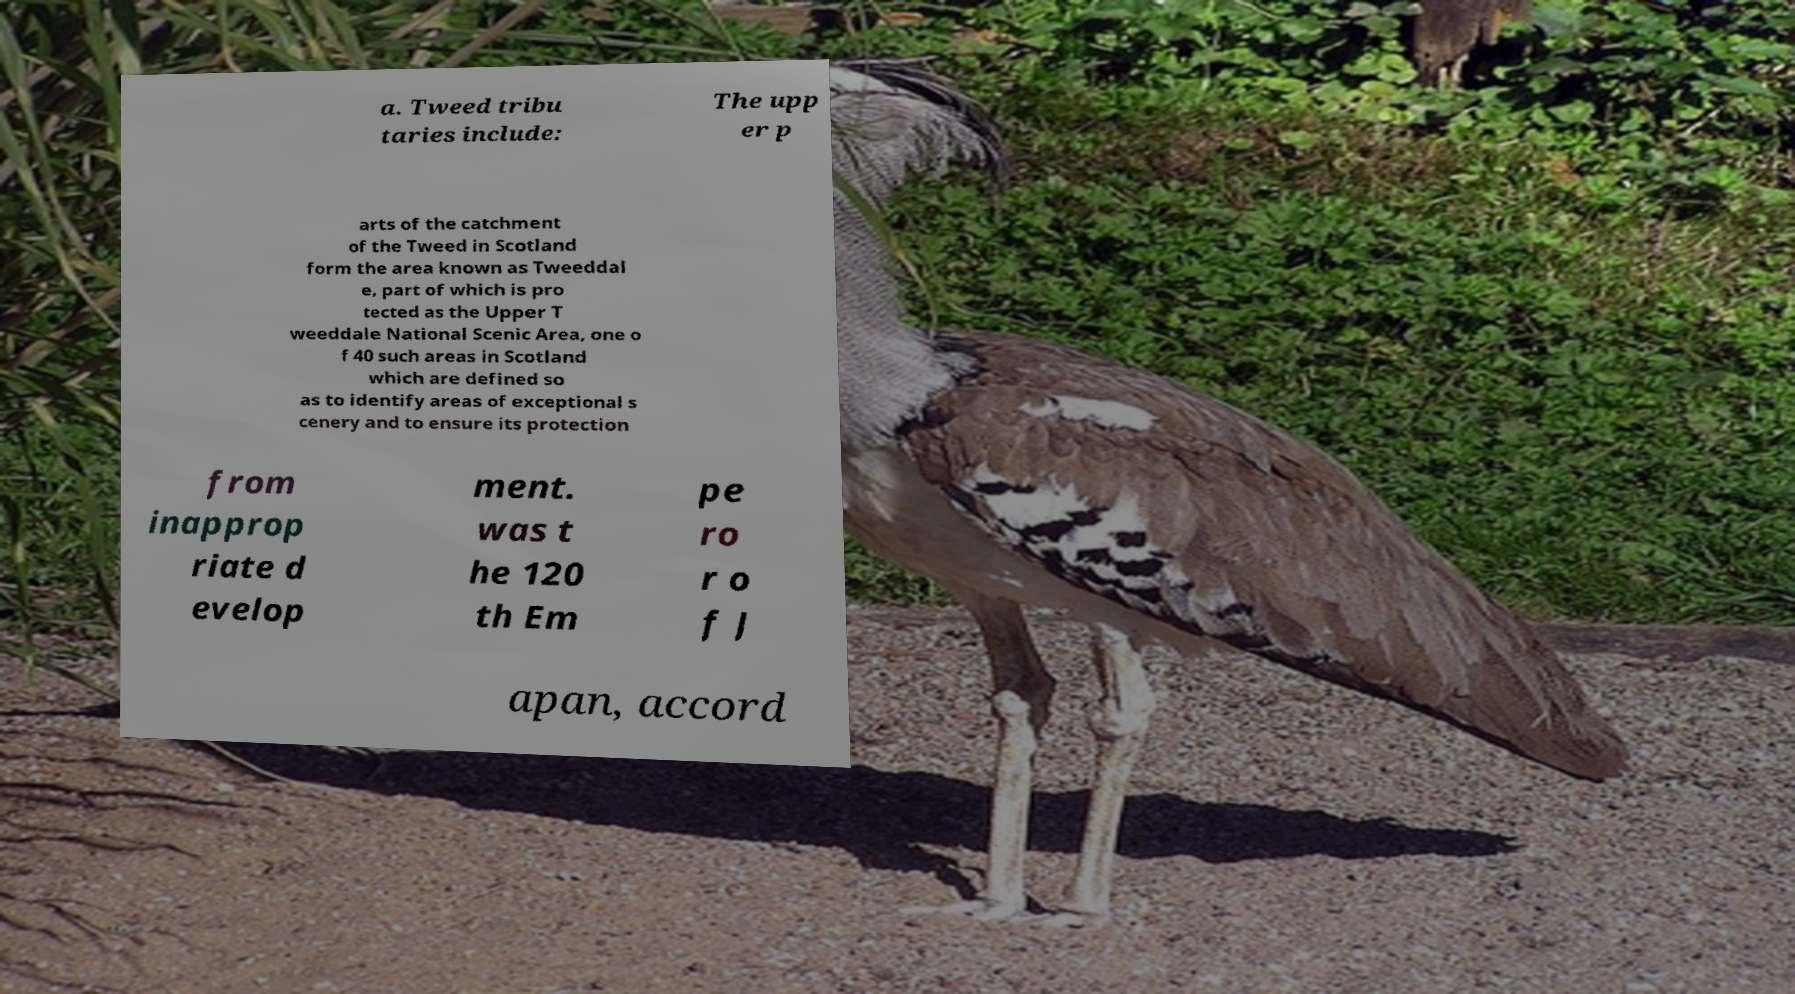For documentation purposes, I need the text within this image transcribed. Could you provide that? a. Tweed tribu taries include: The upp er p arts of the catchment of the Tweed in Scotland form the area known as Tweeddal e, part of which is pro tected as the Upper T weeddale National Scenic Area, one o f 40 such areas in Scotland which are defined so as to identify areas of exceptional s cenery and to ensure its protection from inapprop riate d evelop ment. was t he 120 th Em pe ro r o f J apan, accord 